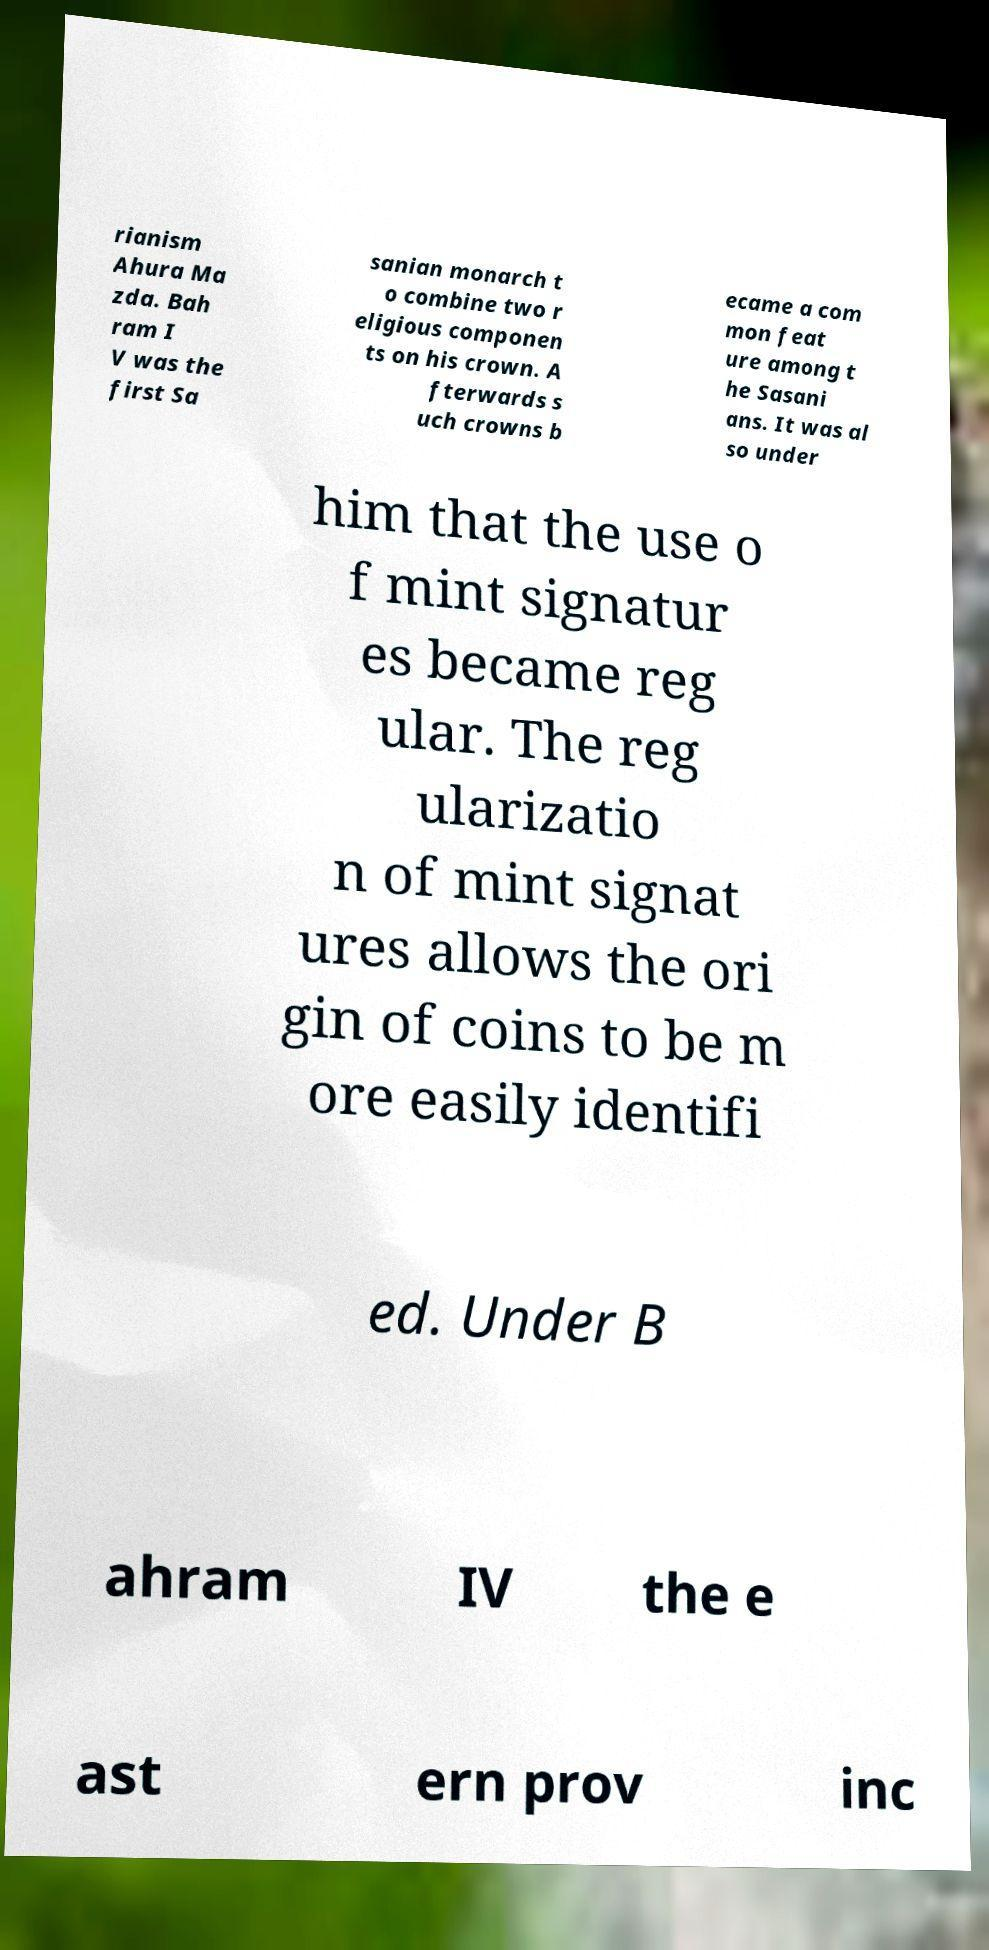Can you read and provide the text displayed in the image?This photo seems to have some interesting text. Can you extract and type it out for me? rianism Ahura Ma zda. Bah ram I V was the first Sa sanian monarch t o combine two r eligious componen ts on his crown. A fterwards s uch crowns b ecame a com mon feat ure among t he Sasani ans. It was al so under him that the use o f mint signatur es became reg ular. The reg ularizatio n of mint signat ures allows the ori gin of coins to be m ore easily identifi ed. Under B ahram IV the e ast ern prov inc 